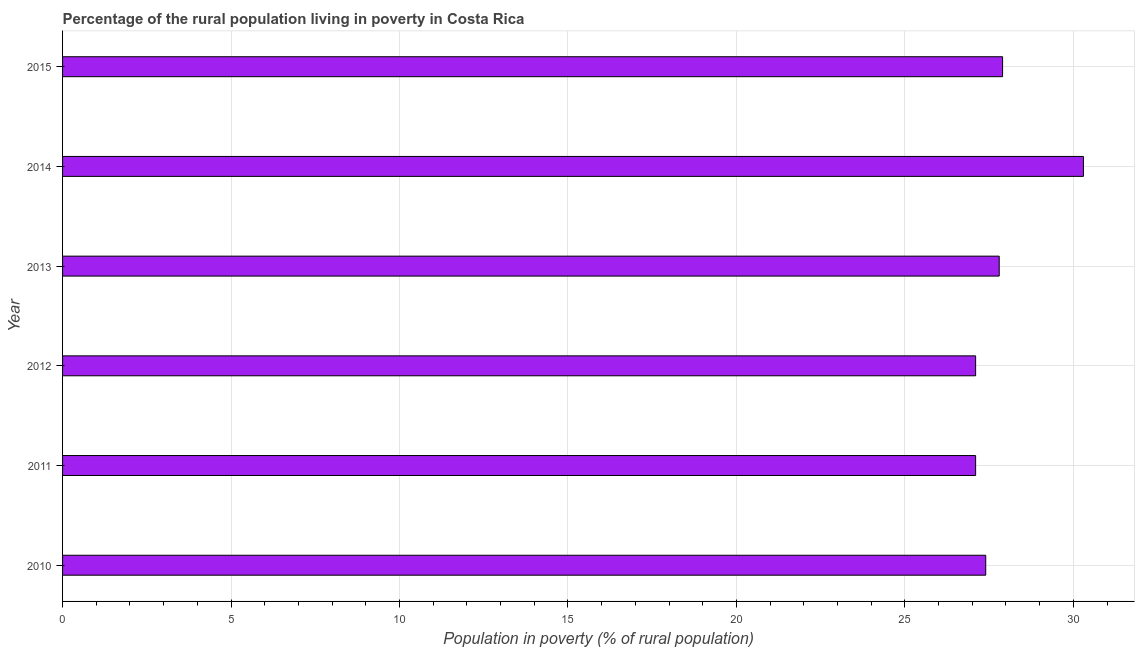What is the title of the graph?
Offer a very short reply. Percentage of the rural population living in poverty in Costa Rica. What is the label or title of the X-axis?
Provide a short and direct response. Population in poverty (% of rural population). What is the percentage of rural population living below poverty line in 2010?
Offer a terse response. 27.4. Across all years, what is the maximum percentage of rural population living below poverty line?
Make the answer very short. 30.3. Across all years, what is the minimum percentage of rural population living below poverty line?
Offer a very short reply. 27.1. In which year was the percentage of rural population living below poverty line maximum?
Your answer should be compact. 2014. What is the sum of the percentage of rural population living below poverty line?
Ensure brevity in your answer.  167.6. What is the difference between the percentage of rural population living below poverty line in 2012 and 2013?
Provide a succinct answer. -0.7. What is the average percentage of rural population living below poverty line per year?
Keep it short and to the point. 27.93. What is the median percentage of rural population living below poverty line?
Keep it short and to the point. 27.6. In how many years, is the percentage of rural population living below poverty line greater than 20 %?
Your answer should be very brief. 6. Do a majority of the years between 2015 and 2010 (inclusive) have percentage of rural population living below poverty line greater than 21 %?
Ensure brevity in your answer.  Yes. Is the difference between the percentage of rural population living below poverty line in 2010 and 2015 greater than the difference between any two years?
Keep it short and to the point. No. What is the difference between the highest and the lowest percentage of rural population living below poverty line?
Keep it short and to the point. 3.2. In how many years, is the percentage of rural population living below poverty line greater than the average percentage of rural population living below poverty line taken over all years?
Offer a very short reply. 1. How many bars are there?
Your response must be concise. 6. Are all the bars in the graph horizontal?
Give a very brief answer. Yes. What is the difference between two consecutive major ticks on the X-axis?
Keep it short and to the point. 5. Are the values on the major ticks of X-axis written in scientific E-notation?
Make the answer very short. No. What is the Population in poverty (% of rural population) in 2010?
Offer a very short reply. 27.4. What is the Population in poverty (% of rural population) of 2011?
Your answer should be very brief. 27.1. What is the Population in poverty (% of rural population) of 2012?
Provide a succinct answer. 27.1. What is the Population in poverty (% of rural population) in 2013?
Give a very brief answer. 27.8. What is the Population in poverty (% of rural population) of 2014?
Ensure brevity in your answer.  30.3. What is the Population in poverty (% of rural population) of 2015?
Your answer should be compact. 27.9. What is the difference between the Population in poverty (% of rural population) in 2010 and 2012?
Keep it short and to the point. 0.3. What is the difference between the Population in poverty (% of rural population) in 2010 and 2013?
Provide a succinct answer. -0.4. What is the difference between the Population in poverty (% of rural population) in 2010 and 2015?
Offer a terse response. -0.5. What is the difference between the Population in poverty (% of rural population) in 2011 and 2013?
Your answer should be very brief. -0.7. What is the difference between the Population in poverty (% of rural population) in 2011 and 2014?
Offer a terse response. -3.2. What is the difference between the Population in poverty (% of rural population) in 2012 and 2015?
Your answer should be very brief. -0.8. What is the difference between the Population in poverty (% of rural population) in 2013 and 2014?
Keep it short and to the point. -2.5. What is the ratio of the Population in poverty (% of rural population) in 2010 to that in 2012?
Make the answer very short. 1.01. What is the ratio of the Population in poverty (% of rural population) in 2010 to that in 2014?
Offer a terse response. 0.9. What is the ratio of the Population in poverty (% of rural population) in 2011 to that in 2012?
Offer a very short reply. 1. What is the ratio of the Population in poverty (% of rural population) in 2011 to that in 2014?
Give a very brief answer. 0.89. What is the ratio of the Population in poverty (% of rural population) in 2012 to that in 2014?
Your response must be concise. 0.89. What is the ratio of the Population in poverty (% of rural population) in 2012 to that in 2015?
Provide a succinct answer. 0.97. What is the ratio of the Population in poverty (% of rural population) in 2013 to that in 2014?
Provide a short and direct response. 0.92. What is the ratio of the Population in poverty (% of rural population) in 2014 to that in 2015?
Your answer should be compact. 1.09. 